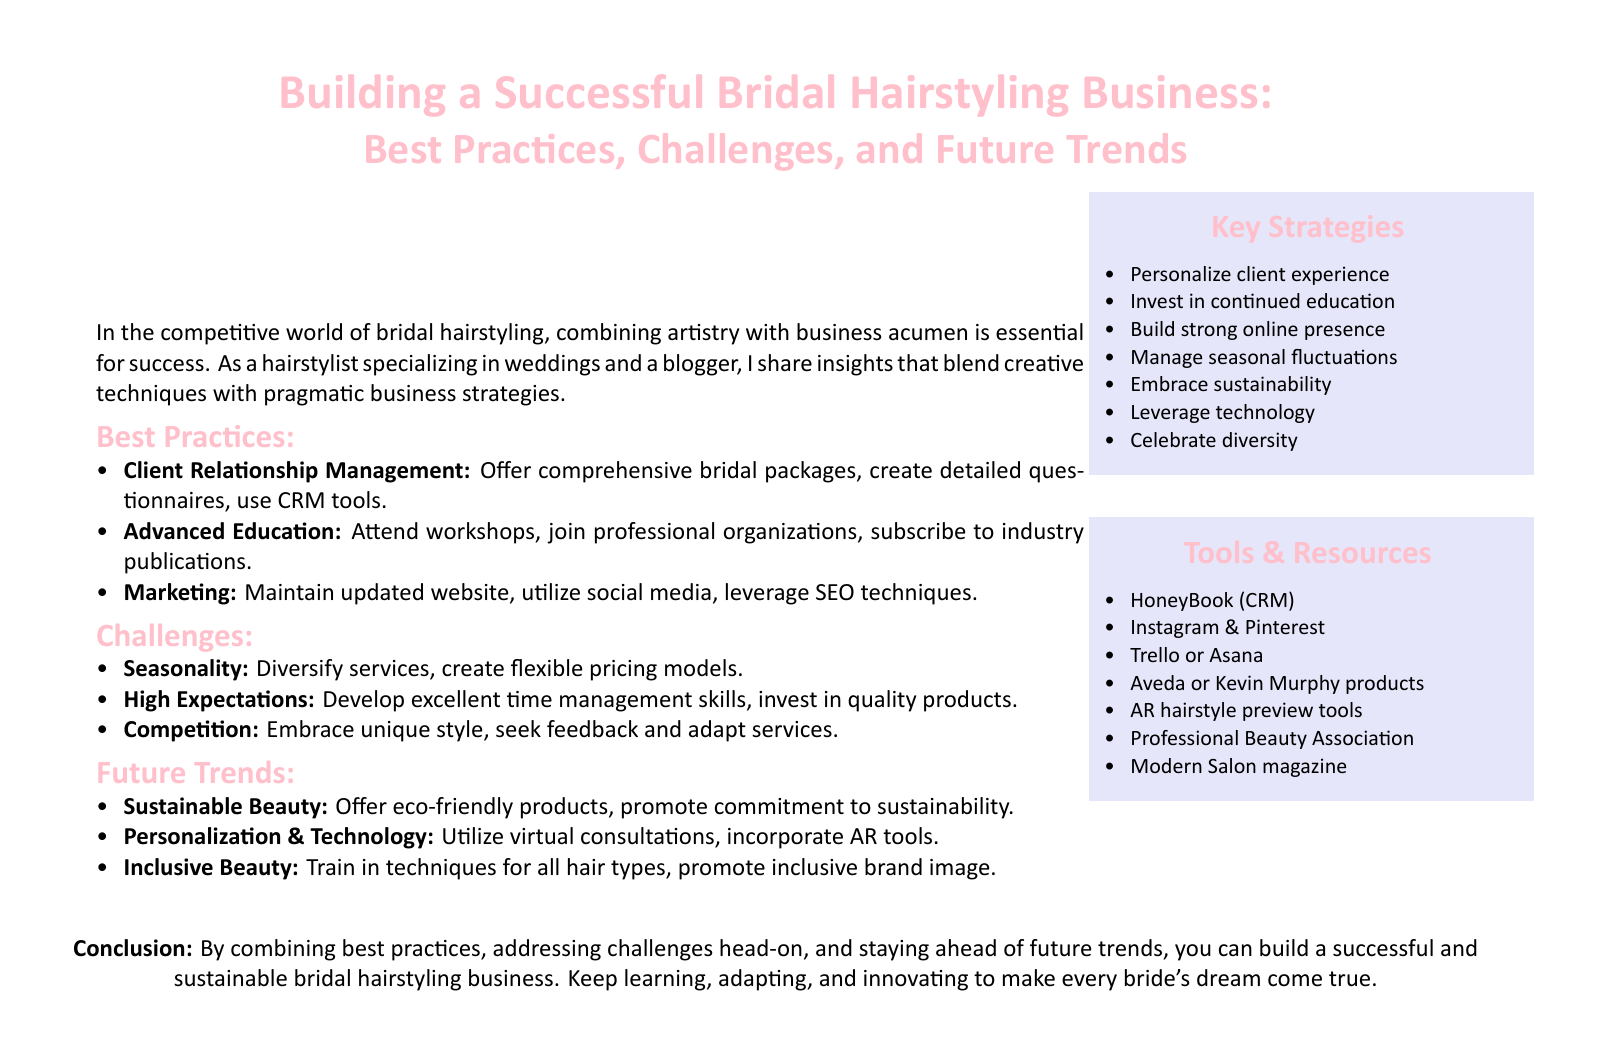what is the main focus of the document? The document focuses on building a successful bridal hairstyling business through best practices.
Answer: bridal hairstyling business name one best practice mentioned in the document. The document lists several best practices, one of which is client relationship management.
Answer: client relationship management how many challenges are listed in the document? The document includes three challenges that bridal hairstylists face.
Answer: three what trend involves technology according to the document? The document mentions personalization and technology as a future trend in bridal hairstyling.
Answer: personalization & technology what is one of the recommended tools for client management? The document suggests using HoneyBook as a CRM tool for managing clients.
Answer: HoneyBook which color theme is used for the document headings? The headings in the document are styled with a specific color, which is a shade of pink.
Answer: pink mention one sustainable practice highlighted in the document. The document includes offering eco-friendly products as a sustainable practice in bridal hairstyling.
Answer: eco-friendly products what is the desired outcome of combining best practices in the bridal hairstyling business? The expected outcome of applying best practices is to build a successful business that meets client needs.
Answer: successful business 